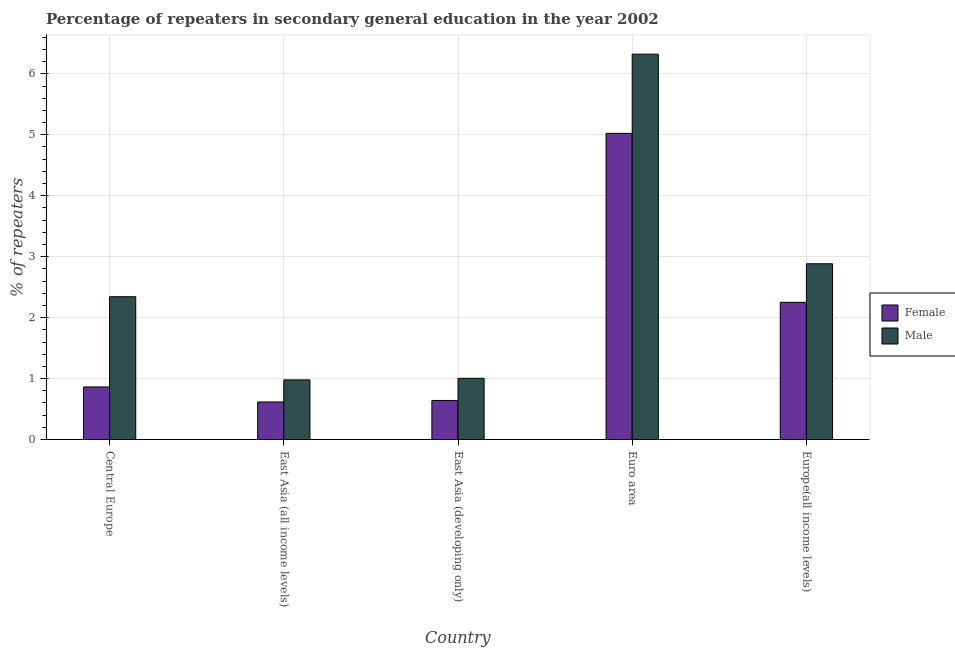How many bars are there on the 4th tick from the left?
Provide a succinct answer. 2. What is the label of the 3rd group of bars from the left?
Give a very brief answer. East Asia (developing only). In how many cases, is the number of bars for a given country not equal to the number of legend labels?
Keep it short and to the point. 0. What is the percentage of female repeaters in East Asia (all income levels)?
Provide a short and direct response. 0.62. Across all countries, what is the maximum percentage of female repeaters?
Provide a short and direct response. 5.02. Across all countries, what is the minimum percentage of female repeaters?
Your response must be concise. 0.62. In which country was the percentage of male repeaters maximum?
Provide a short and direct response. Euro area. In which country was the percentage of female repeaters minimum?
Keep it short and to the point. East Asia (all income levels). What is the total percentage of male repeaters in the graph?
Offer a very short reply. 13.53. What is the difference between the percentage of male repeaters in East Asia (developing only) and that in Euro area?
Keep it short and to the point. -5.32. What is the difference between the percentage of female repeaters in Euro area and the percentage of male repeaters in East Asia (all income levels)?
Offer a terse response. 4.05. What is the average percentage of female repeaters per country?
Give a very brief answer. 1.88. What is the difference between the percentage of male repeaters and percentage of female repeaters in Central Europe?
Your response must be concise. 1.48. What is the ratio of the percentage of male repeaters in East Asia (developing only) to that in Europe(all income levels)?
Keep it short and to the point. 0.35. What is the difference between the highest and the second highest percentage of male repeaters?
Your answer should be compact. 3.44. What is the difference between the highest and the lowest percentage of female repeaters?
Offer a very short reply. 4.41. In how many countries, is the percentage of female repeaters greater than the average percentage of female repeaters taken over all countries?
Make the answer very short. 2. Is the sum of the percentage of female repeaters in East Asia (developing only) and Europe(all income levels) greater than the maximum percentage of male repeaters across all countries?
Your answer should be very brief. No. What does the 1st bar from the left in Europe(all income levels) represents?
Your answer should be compact. Female. What does the 1st bar from the right in Central Europe represents?
Your response must be concise. Male. How many bars are there?
Make the answer very short. 10. What is the difference between two consecutive major ticks on the Y-axis?
Provide a succinct answer. 1. Does the graph contain any zero values?
Keep it short and to the point. No. Does the graph contain grids?
Keep it short and to the point. Yes. Where does the legend appear in the graph?
Provide a short and direct response. Center right. How are the legend labels stacked?
Make the answer very short. Vertical. What is the title of the graph?
Your answer should be compact. Percentage of repeaters in secondary general education in the year 2002. Does "Birth rate" appear as one of the legend labels in the graph?
Provide a succinct answer. No. What is the label or title of the Y-axis?
Make the answer very short. % of repeaters. What is the % of repeaters in Female in Central Europe?
Offer a very short reply. 0.86. What is the % of repeaters in Male in Central Europe?
Ensure brevity in your answer.  2.34. What is the % of repeaters of Female in East Asia (all income levels)?
Provide a short and direct response. 0.62. What is the % of repeaters of Male in East Asia (all income levels)?
Offer a terse response. 0.98. What is the % of repeaters in Female in East Asia (developing only)?
Your answer should be compact. 0.64. What is the % of repeaters of Male in East Asia (developing only)?
Make the answer very short. 1. What is the % of repeaters of Female in Euro area?
Your answer should be very brief. 5.02. What is the % of repeaters of Male in Euro area?
Provide a short and direct response. 6.32. What is the % of repeaters in Female in Europe(all income levels)?
Keep it short and to the point. 2.25. What is the % of repeaters of Male in Europe(all income levels)?
Provide a short and direct response. 2.88. Across all countries, what is the maximum % of repeaters of Female?
Offer a terse response. 5.02. Across all countries, what is the maximum % of repeaters of Male?
Provide a succinct answer. 6.32. Across all countries, what is the minimum % of repeaters in Female?
Make the answer very short. 0.62. Across all countries, what is the minimum % of repeaters in Male?
Offer a terse response. 0.98. What is the total % of repeaters of Female in the graph?
Provide a short and direct response. 9.39. What is the total % of repeaters of Male in the graph?
Provide a succinct answer. 13.53. What is the difference between the % of repeaters in Female in Central Europe and that in East Asia (all income levels)?
Ensure brevity in your answer.  0.25. What is the difference between the % of repeaters in Male in Central Europe and that in East Asia (all income levels)?
Ensure brevity in your answer.  1.36. What is the difference between the % of repeaters in Female in Central Europe and that in East Asia (developing only)?
Give a very brief answer. 0.22. What is the difference between the % of repeaters of Male in Central Europe and that in East Asia (developing only)?
Offer a terse response. 1.34. What is the difference between the % of repeaters in Female in Central Europe and that in Euro area?
Keep it short and to the point. -4.16. What is the difference between the % of repeaters in Male in Central Europe and that in Euro area?
Keep it short and to the point. -3.98. What is the difference between the % of repeaters of Female in Central Europe and that in Europe(all income levels)?
Make the answer very short. -1.39. What is the difference between the % of repeaters in Male in Central Europe and that in Europe(all income levels)?
Offer a terse response. -0.54. What is the difference between the % of repeaters in Female in East Asia (all income levels) and that in East Asia (developing only)?
Make the answer very short. -0.02. What is the difference between the % of repeaters in Male in East Asia (all income levels) and that in East Asia (developing only)?
Ensure brevity in your answer.  -0.03. What is the difference between the % of repeaters of Female in East Asia (all income levels) and that in Euro area?
Make the answer very short. -4.41. What is the difference between the % of repeaters of Male in East Asia (all income levels) and that in Euro area?
Provide a short and direct response. -5.34. What is the difference between the % of repeaters of Female in East Asia (all income levels) and that in Europe(all income levels)?
Offer a very short reply. -1.63. What is the difference between the % of repeaters in Male in East Asia (all income levels) and that in Europe(all income levels)?
Offer a terse response. -1.91. What is the difference between the % of repeaters in Female in East Asia (developing only) and that in Euro area?
Your answer should be compact. -4.38. What is the difference between the % of repeaters of Male in East Asia (developing only) and that in Euro area?
Provide a succinct answer. -5.32. What is the difference between the % of repeaters of Female in East Asia (developing only) and that in Europe(all income levels)?
Offer a very short reply. -1.61. What is the difference between the % of repeaters in Male in East Asia (developing only) and that in Europe(all income levels)?
Your response must be concise. -1.88. What is the difference between the % of repeaters in Female in Euro area and that in Europe(all income levels)?
Give a very brief answer. 2.77. What is the difference between the % of repeaters in Male in Euro area and that in Europe(all income levels)?
Your answer should be compact. 3.44. What is the difference between the % of repeaters in Female in Central Europe and the % of repeaters in Male in East Asia (all income levels)?
Your response must be concise. -0.12. What is the difference between the % of repeaters of Female in Central Europe and the % of repeaters of Male in East Asia (developing only)?
Ensure brevity in your answer.  -0.14. What is the difference between the % of repeaters in Female in Central Europe and the % of repeaters in Male in Euro area?
Offer a very short reply. -5.46. What is the difference between the % of repeaters in Female in Central Europe and the % of repeaters in Male in Europe(all income levels)?
Make the answer very short. -2.02. What is the difference between the % of repeaters in Female in East Asia (all income levels) and the % of repeaters in Male in East Asia (developing only)?
Keep it short and to the point. -0.39. What is the difference between the % of repeaters in Female in East Asia (all income levels) and the % of repeaters in Male in Euro area?
Offer a terse response. -5.71. What is the difference between the % of repeaters of Female in East Asia (all income levels) and the % of repeaters of Male in Europe(all income levels)?
Make the answer very short. -2.27. What is the difference between the % of repeaters of Female in East Asia (developing only) and the % of repeaters of Male in Euro area?
Your answer should be compact. -5.68. What is the difference between the % of repeaters of Female in East Asia (developing only) and the % of repeaters of Male in Europe(all income levels)?
Your response must be concise. -2.24. What is the difference between the % of repeaters of Female in Euro area and the % of repeaters of Male in Europe(all income levels)?
Keep it short and to the point. 2.14. What is the average % of repeaters of Female per country?
Make the answer very short. 1.88. What is the average % of repeaters in Male per country?
Provide a short and direct response. 2.71. What is the difference between the % of repeaters of Female and % of repeaters of Male in Central Europe?
Your answer should be compact. -1.48. What is the difference between the % of repeaters in Female and % of repeaters in Male in East Asia (all income levels)?
Ensure brevity in your answer.  -0.36. What is the difference between the % of repeaters of Female and % of repeaters of Male in East Asia (developing only)?
Your answer should be compact. -0.36. What is the difference between the % of repeaters in Female and % of repeaters in Male in Euro area?
Your response must be concise. -1.3. What is the difference between the % of repeaters of Female and % of repeaters of Male in Europe(all income levels)?
Your answer should be compact. -0.63. What is the ratio of the % of repeaters in Female in Central Europe to that in East Asia (all income levels)?
Provide a short and direct response. 1.4. What is the ratio of the % of repeaters of Male in Central Europe to that in East Asia (all income levels)?
Give a very brief answer. 2.39. What is the ratio of the % of repeaters of Female in Central Europe to that in East Asia (developing only)?
Offer a very short reply. 1.35. What is the ratio of the % of repeaters of Male in Central Europe to that in East Asia (developing only)?
Provide a succinct answer. 2.33. What is the ratio of the % of repeaters in Female in Central Europe to that in Euro area?
Your answer should be very brief. 0.17. What is the ratio of the % of repeaters in Male in Central Europe to that in Euro area?
Provide a succinct answer. 0.37. What is the ratio of the % of repeaters in Female in Central Europe to that in Europe(all income levels)?
Offer a very short reply. 0.38. What is the ratio of the % of repeaters in Male in Central Europe to that in Europe(all income levels)?
Provide a succinct answer. 0.81. What is the ratio of the % of repeaters of Female in East Asia (all income levels) to that in East Asia (developing only)?
Give a very brief answer. 0.96. What is the ratio of the % of repeaters in Male in East Asia (all income levels) to that in East Asia (developing only)?
Your response must be concise. 0.97. What is the ratio of the % of repeaters of Female in East Asia (all income levels) to that in Euro area?
Offer a very short reply. 0.12. What is the ratio of the % of repeaters in Male in East Asia (all income levels) to that in Euro area?
Offer a terse response. 0.15. What is the ratio of the % of repeaters in Female in East Asia (all income levels) to that in Europe(all income levels)?
Provide a succinct answer. 0.27. What is the ratio of the % of repeaters of Male in East Asia (all income levels) to that in Europe(all income levels)?
Keep it short and to the point. 0.34. What is the ratio of the % of repeaters of Female in East Asia (developing only) to that in Euro area?
Offer a very short reply. 0.13. What is the ratio of the % of repeaters in Male in East Asia (developing only) to that in Euro area?
Offer a terse response. 0.16. What is the ratio of the % of repeaters of Female in East Asia (developing only) to that in Europe(all income levels)?
Your answer should be very brief. 0.28. What is the ratio of the % of repeaters in Male in East Asia (developing only) to that in Europe(all income levels)?
Your answer should be compact. 0.35. What is the ratio of the % of repeaters of Female in Euro area to that in Europe(all income levels)?
Offer a very short reply. 2.23. What is the ratio of the % of repeaters in Male in Euro area to that in Europe(all income levels)?
Make the answer very short. 2.19. What is the difference between the highest and the second highest % of repeaters in Female?
Your answer should be very brief. 2.77. What is the difference between the highest and the second highest % of repeaters of Male?
Keep it short and to the point. 3.44. What is the difference between the highest and the lowest % of repeaters in Female?
Keep it short and to the point. 4.41. What is the difference between the highest and the lowest % of repeaters of Male?
Your answer should be very brief. 5.34. 